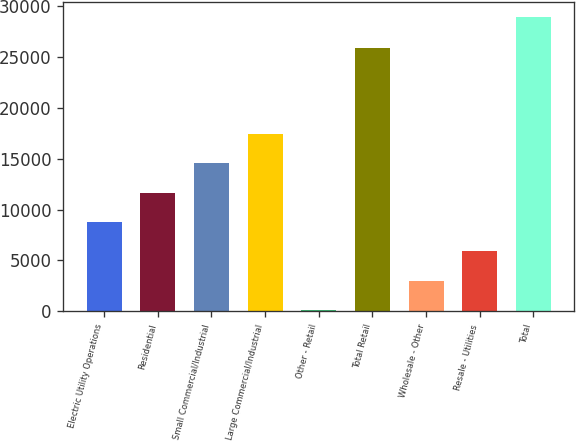<chart> <loc_0><loc_0><loc_500><loc_500><bar_chart><fcel>Electric Utility Operations<fcel>Residential<fcel>Small Commercial/Industrial<fcel>Large Commercial/Industrial<fcel>Other - Retail<fcel>Total Retail<fcel>Wholesale - Other<fcel>Resale - Utilities<fcel>Total<nl><fcel>8778.35<fcel>11652.3<fcel>14526.2<fcel>17400.2<fcel>156.5<fcel>25817.7<fcel>3030.45<fcel>5904.4<fcel>28896<nl></chart> 